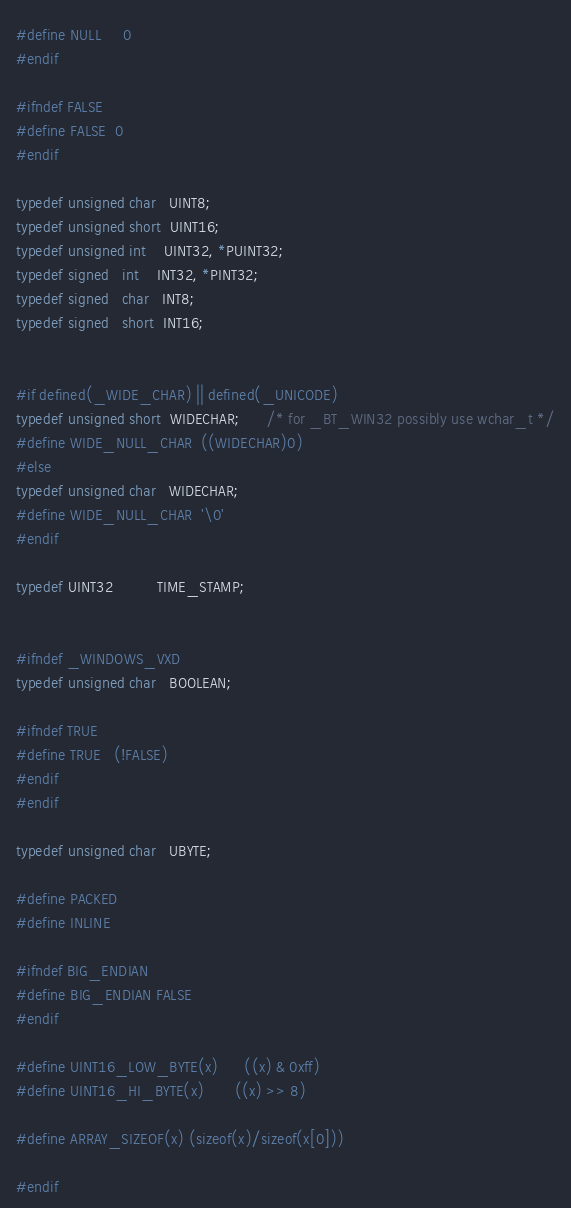Convert code to text. <code><loc_0><loc_0><loc_500><loc_500><_C_>#define NULL     0
#endif

#ifndef FALSE
#define FALSE  0
#endif

typedef unsigned char   UINT8;
typedef unsigned short  UINT16;
typedef unsigned int    UINT32, *PUINT32;
typedef signed   int    INT32, *PINT32;
typedef signed   char   INT8;
typedef signed   short  INT16;


#if defined(_WIDE_CHAR) || defined(_UNICODE)
typedef unsigned short  WIDECHAR;      /* for _BT_WIN32 possibly use wchar_t */
#define WIDE_NULL_CHAR  ((WIDECHAR)0)
#else
typedef unsigned char   WIDECHAR;
#define WIDE_NULL_CHAR  '\0'
#endif

typedef UINT32          TIME_STAMP;


#ifndef _WINDOWS_VXD
typedef unsigned char   BOOLEAN;

#ifndef TRUE
#define TRUE   (!FALSE)
#endif
#endif

typedef unsigned char   UBYTE;

#define PACKED
#define INLINE

#ifndef BIG_ENDIAN
#define BIG_ENDIAN FALSE
#endif

#define UINT16_LOW_BYTE(x)      ((x) & 0xff)
#define UINT16_HI_BYTE(x)       ((x) >> 8)

#define ARRAY_SIZEOF(x) (sizeof(x)/sizeof(x[0]))

#endif
</code> 